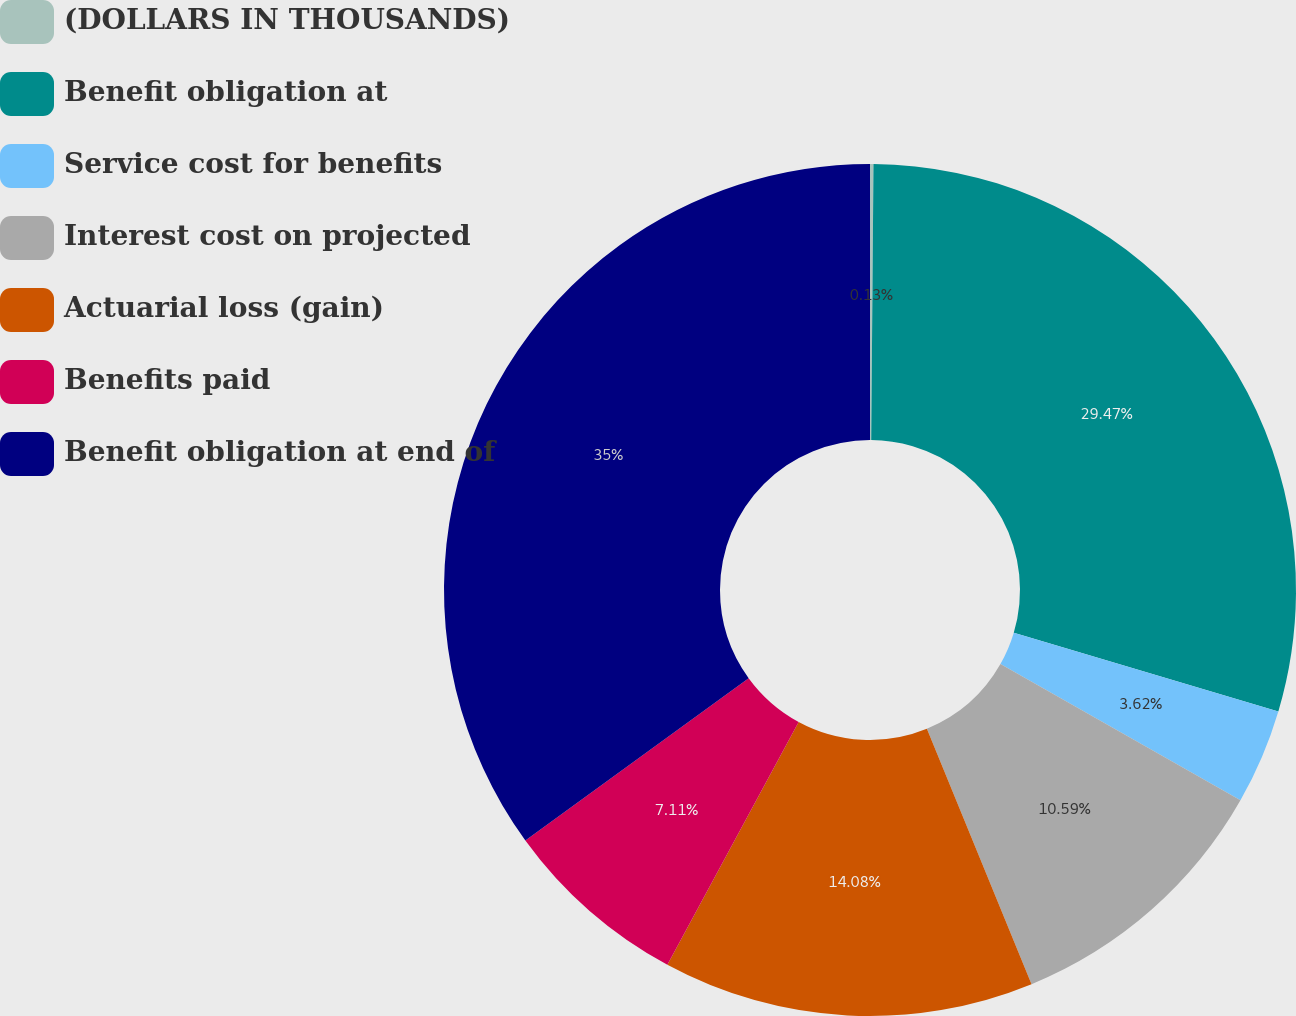Convert chart. <chart><loc_0><loc_0><loc_500><loc_500><pie_chart><fcel>(DOLLARS IN THOUSANDS)<fcel>Benefit obligation at<fcel>Service cost for benefits<fcel>Interest cost on projected<fcel>Actuarial loss (gain)<fcel>Benefits paid<fcel>Benefit obligation at end of<nl><fcel>0.13%<fcel>29.47%<fcel>3.62%<fcel>10.59%<fcel>14.08%<fcel>7.11%<fcel>35.0%<nl></chart> 